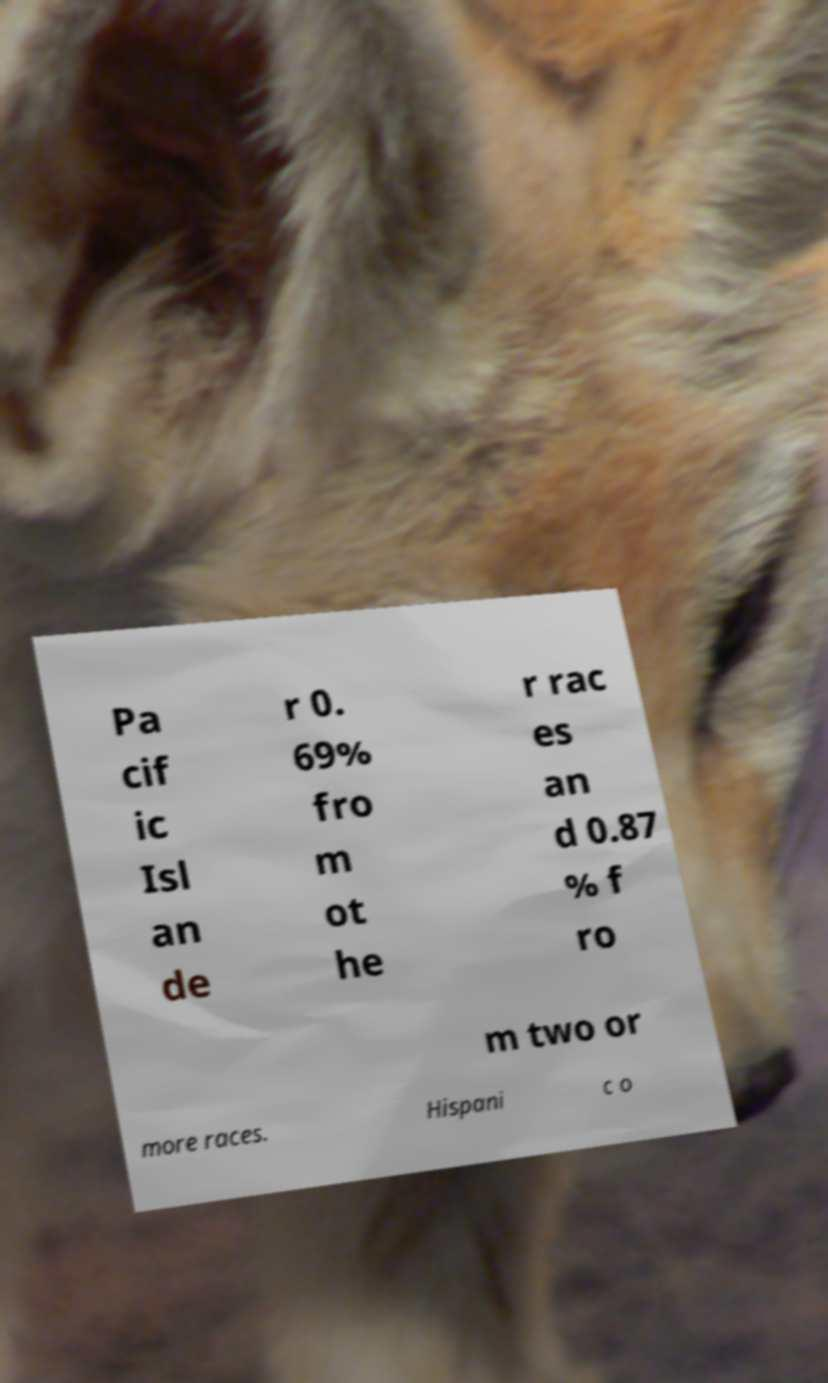Could you extract and type out the text from this image? Pa cif ic Isl an de r 0. 69% fro m ot he r rac es an d 0.87 % f ro m two or more races. Hispani c o 